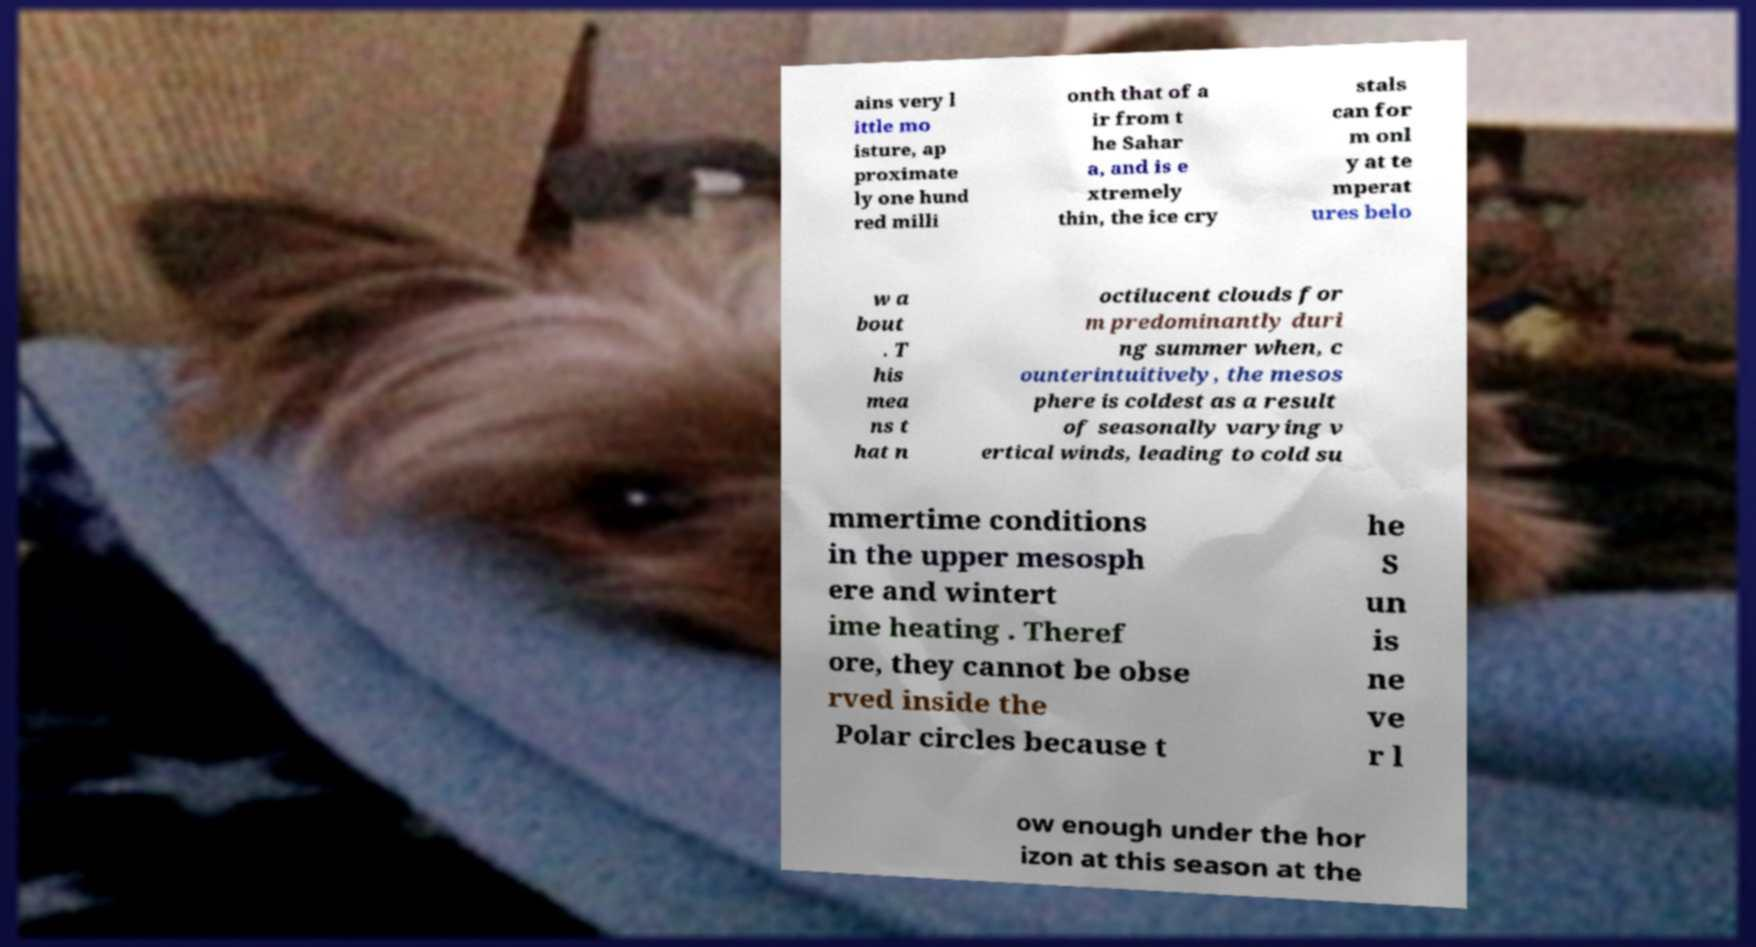Could you extract and type out the text from this image? ains very l ittle mo isture, ap proximate ly one hund red milli onth that of a ir from t he Sahar a, and is e xtremely thin, the ice cry stals can for m onl y at te mperat ures belo w a bout . T his mea ns t hat n octilucent clouds for m predominantly duri ng summer when, c ounterintuitively, the mesos phere is coldest as a result of seasonally varying v ertical winds, leading to cold su mmertime conditions in the upper mesosph ere and wintert ime heating . Theref ore, they cannot be obse rved inside the Polar circles because t he S un is ne ve r l ow enough under the hor izon at this season at the 